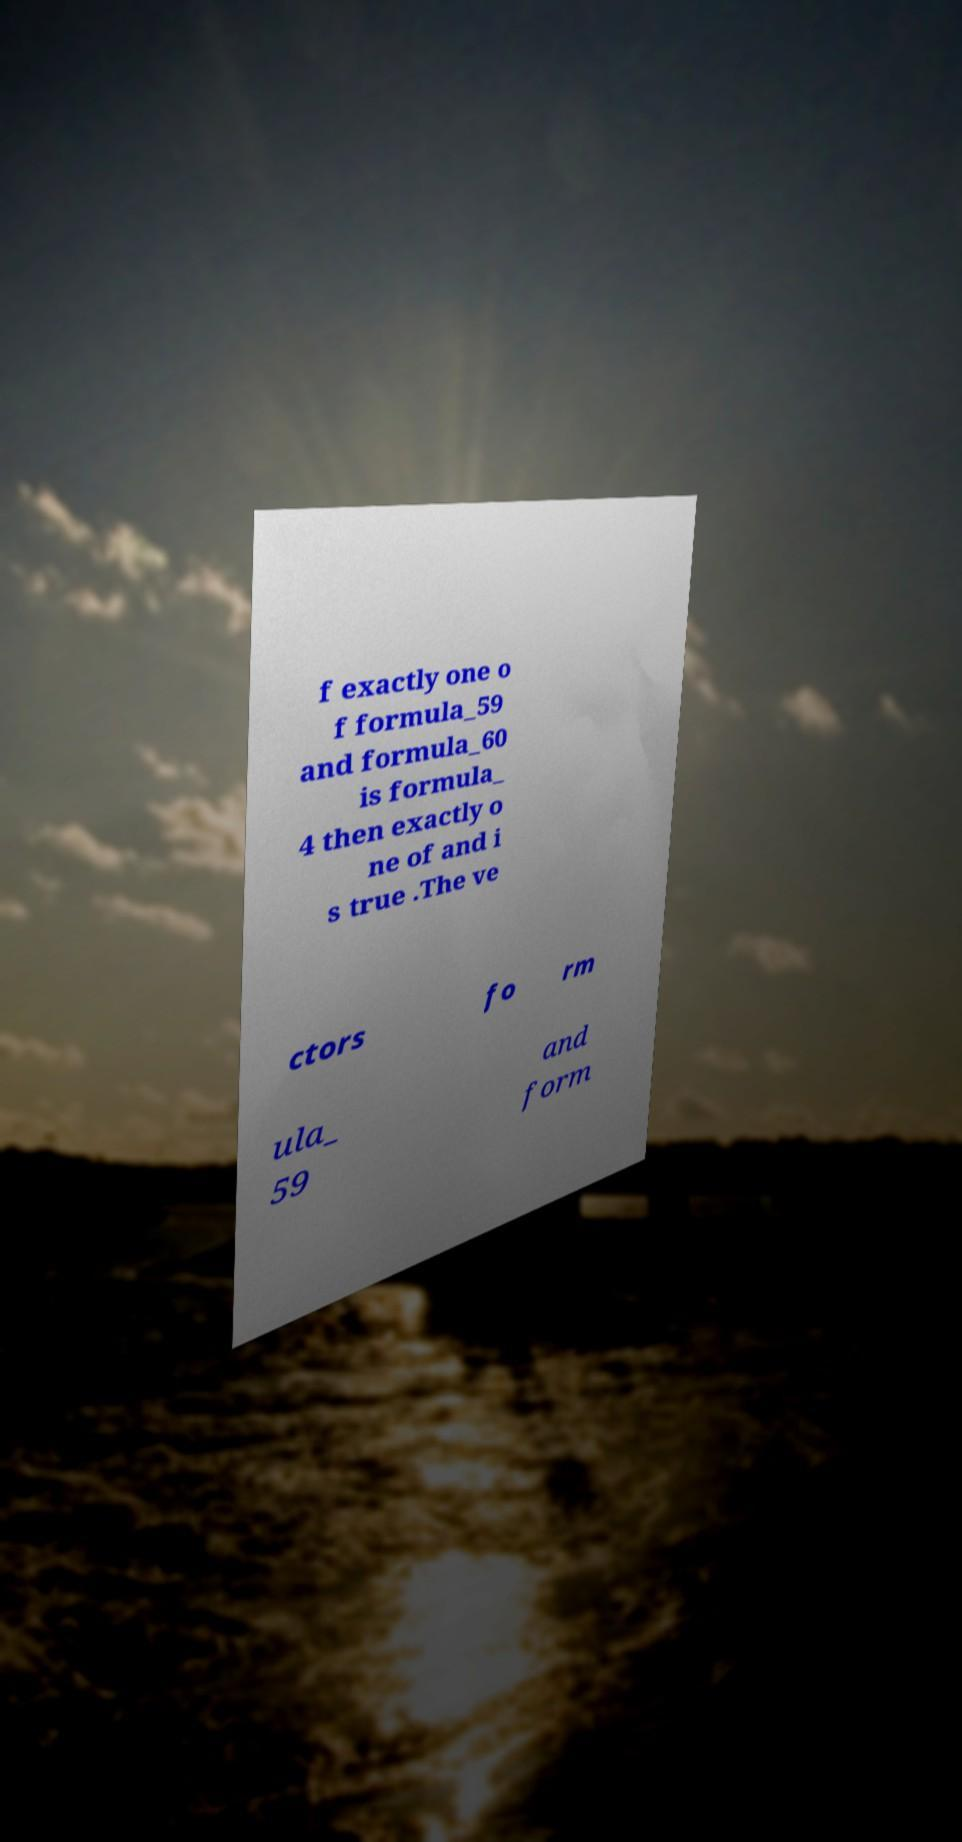What messages or text are displayed in this image? I need them in a readable, typed format. f exactly one o f formula_59 and formula_60 is formula_ 4 then exactly o ne of and i s true .The ve ctors fo rm ula_ 59 and form 